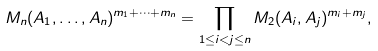Convert formula to latex. <formula><loc_0><loc_0><loc_500><loc_500>M _ { n } ( A _ { 1 } , \dots , A _ { n } ) ^ { m _ { 1 } + \cdots + m _ { n } } = \prod _ { 1 \leq i < j \leq n } M _ { 2 } ( A _ { i } , A _ { j } ) ^ { m _ { i } + m _ { j } } ,</formula> 